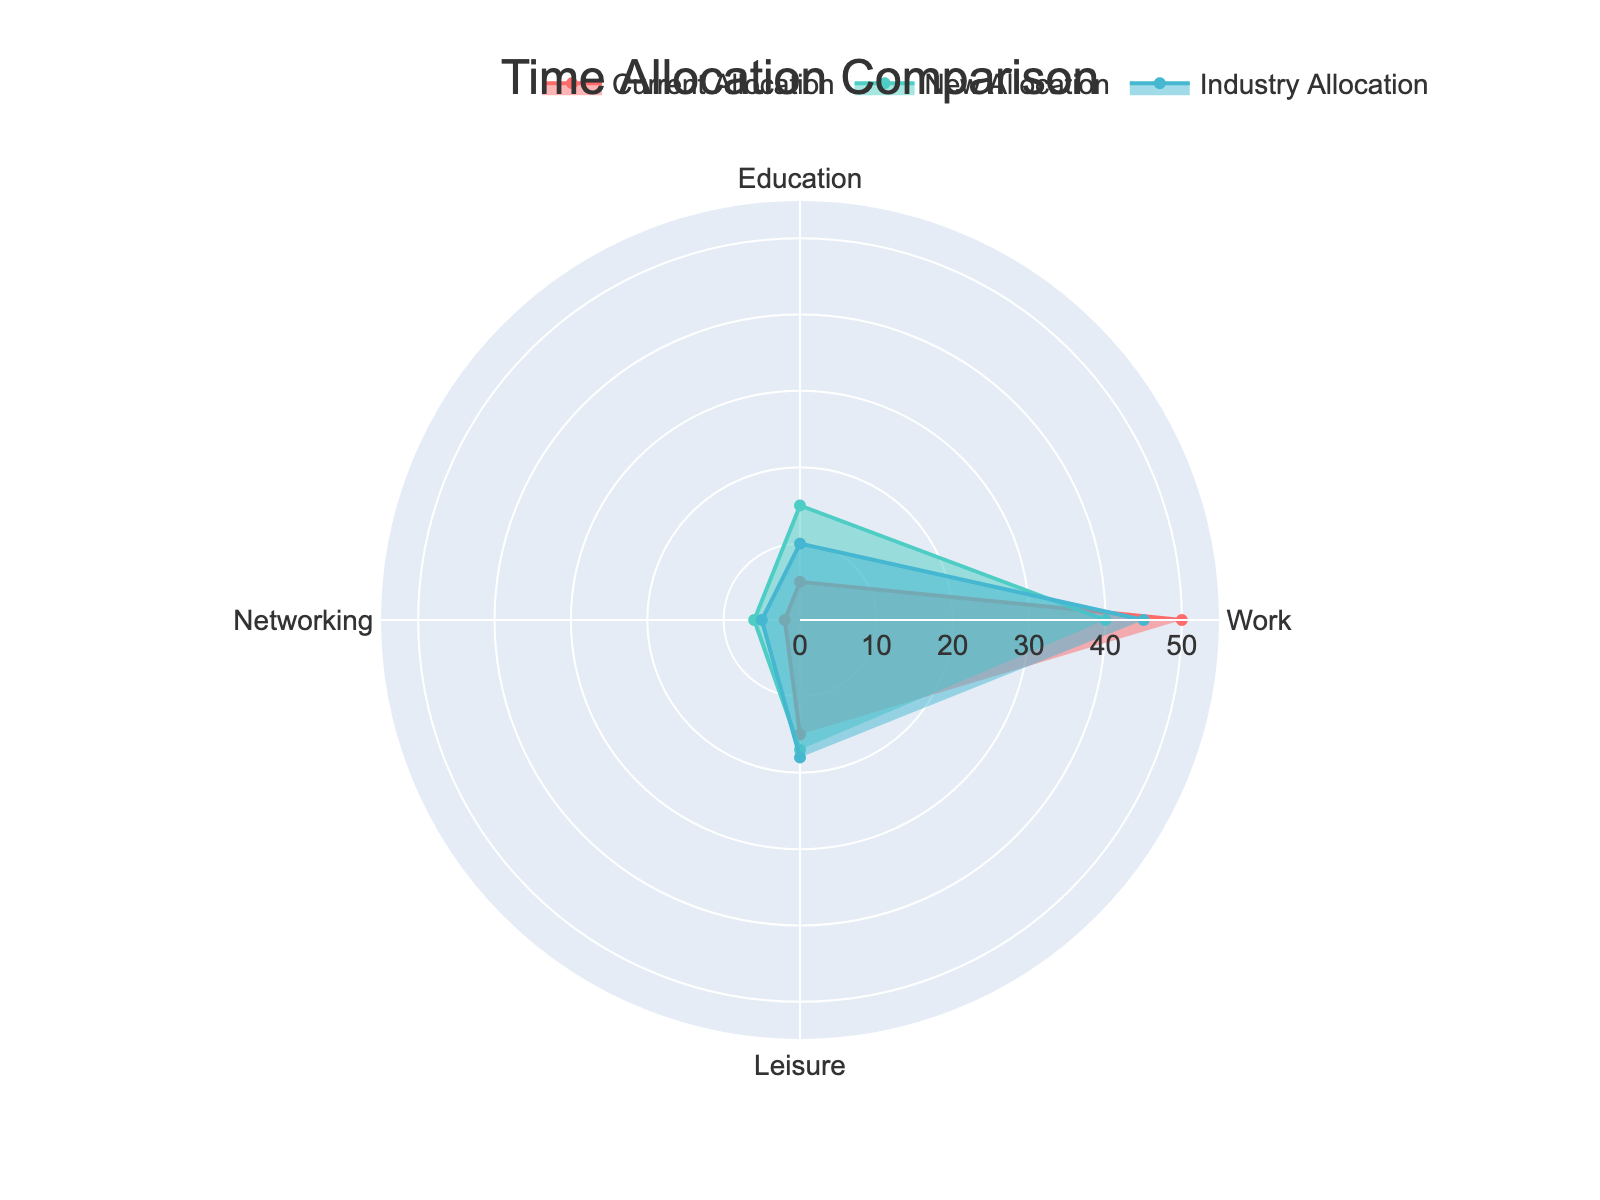How many categories are shown in the radar chart? The radar chart displays four distinct categories: Work, Education, Networking, and Leisure.
Answer: Four What is the title of the radar chart? The title of the radar chart is "Time Allocation Comparison."
Answer: Time Allocation Comparison Which category has the highest current allocation of hours per week? By examining the radar chart, the Work category has the highest current allocation at 50 hours per week.
Answer: Work What is the difference between the new allocation and the current allocation for the Education category? The new allocation for Education is 15 hours per week, while the current allocation is 5 hours per week. The difference is 15 - 5 = 10 hours per week.
Answer: 10 hours How does the industry allocation for Networking compare to the new allocation for Networking? The industry allocation for Networking is 5 hours per week, whereas the new allocation is 6 hours per week. The new allocation is 1 hour more than the industry allocation.
Answer: 1 hour more Which category has the smallest change between current allocation and new allocation? By comparing the current and new allocations for all categories, Leisure has the smallest change, increasing from 15 to 17 hours, a difference of 2 hours.
Answer: Leisure What is the average of the current allocations for all categories? To find the average, sum the current allocations (50 + 5 + 2 + 15) = 72 hours, then divide by the number of categories (4). 72 / 4 = 18 hours.
Answer: 18 hours Which category has the closest match between new allocation and industry allocation? Comparing the new and industry allocations for all categories, the allocations for Networking are 6 and 5 hours respectively, a difference of 1 hour, the smallest among all categories.
Answer: Networking How much more time is allocated to Education in the new allocation compared to the current allocation? The current allocation for Education is 5 hours per week, and the new allocation is 15 hours per week. The difference is 15 - 5 = 10 hours.
Answer: 10 hours Does the Leisure category have a higher industry allocation or new allocation? The industry allocation for Leisure is 18 hours per week, while the new allocation is 17 hours per week. The industry allocation is higher by 1 hour.
Answer: Industry allocation 